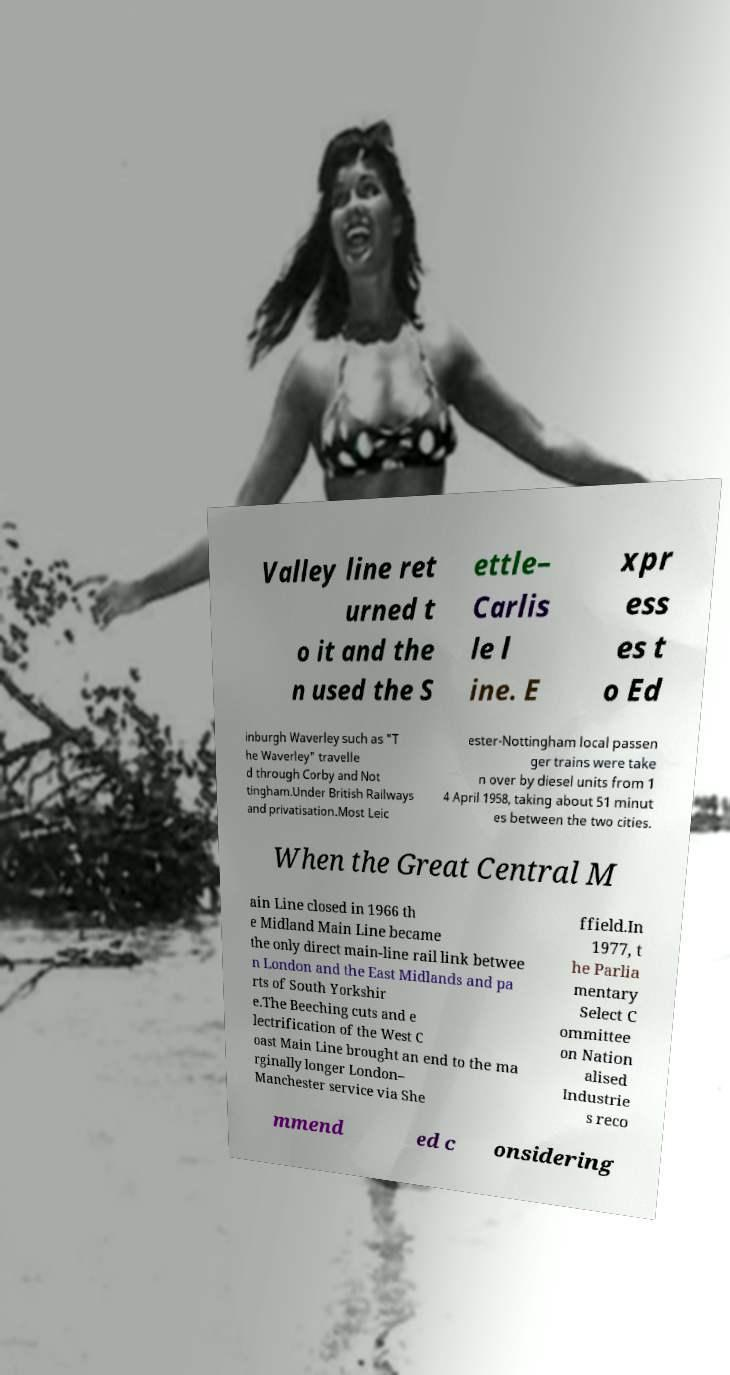Please read and relay the text visible in this image. What does it say? Valley line ret urned t o it and the n used the S ettle– Carlis le l ine. E xpr ess es t o Ed inburgh Waverley such as "T he Waverley" travelle d through Corby and Not tingham.Under British Railways and privatisation.Most Leic ester-Nottingham local passen ger trains were take n over by diesel units from 1 4 April 1958, taking about 51 minut es between the two cities. When the Great Central M ain Line closed in 1966 th e Midland Main Line became the only direct main-line rail link betwee n London and the East Midlands and pa rts of South Yorkshir e.The Beeching cuts and e lectrification of the West C oast Main Line brought an end to the ma rginally longer London– Manchester service via She ffield.In 1977, t he Parlia mentary Select C ommittee on Nation alised Industrie s reco mmend ed c onsidering 